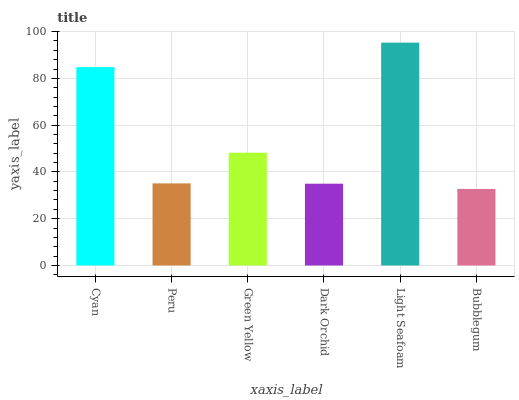Is Bubblegum the minimum?
Answer yes or no. Yes. Is Light Seafoam the maximum?
Answer yes or no. Yes. Is Peru the minimum?
Answer yes or no. No. Is Peru the maximum?
Answer yes or no. No. Is Cyan greater than Peru?
Answer yes or no. Yes. Is Peru less than Cyan?
Answer yes or no. Yes. Is Peru greater than Cyan?
Answer yes or no. No. Is Cyan less than Peru?
Answer yes or no. No. Is Green Yellow the high median?
Answer yes or no. Yes. Is Peru the low median?
Answer yes or no. Yes. Is Light Seafoam the high median?
Answer yes or no. No. Is Green Yellow the low median?
Answer yes or no. No. 